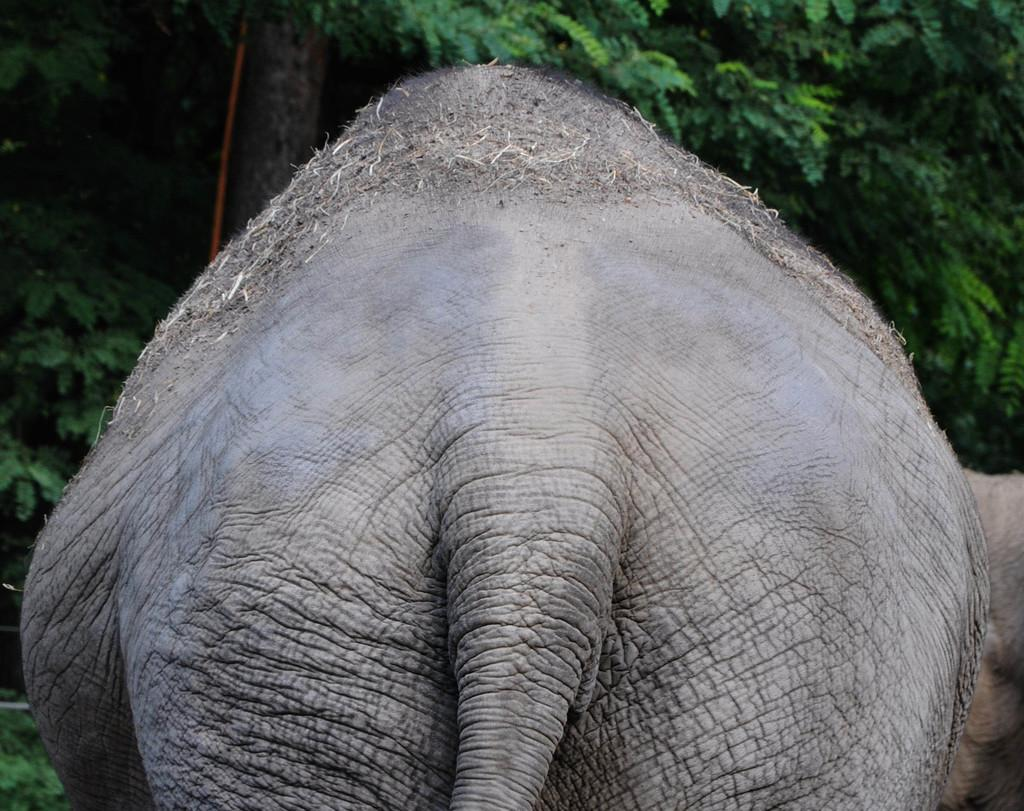What animal is present in the image? There is an elephant in the image. What can be seen in the background of the image? There are trees in the background of the image. What type of fruit is the elephant holding in the image? There is no fruit present in the image, and the elephant is not holding anything. 